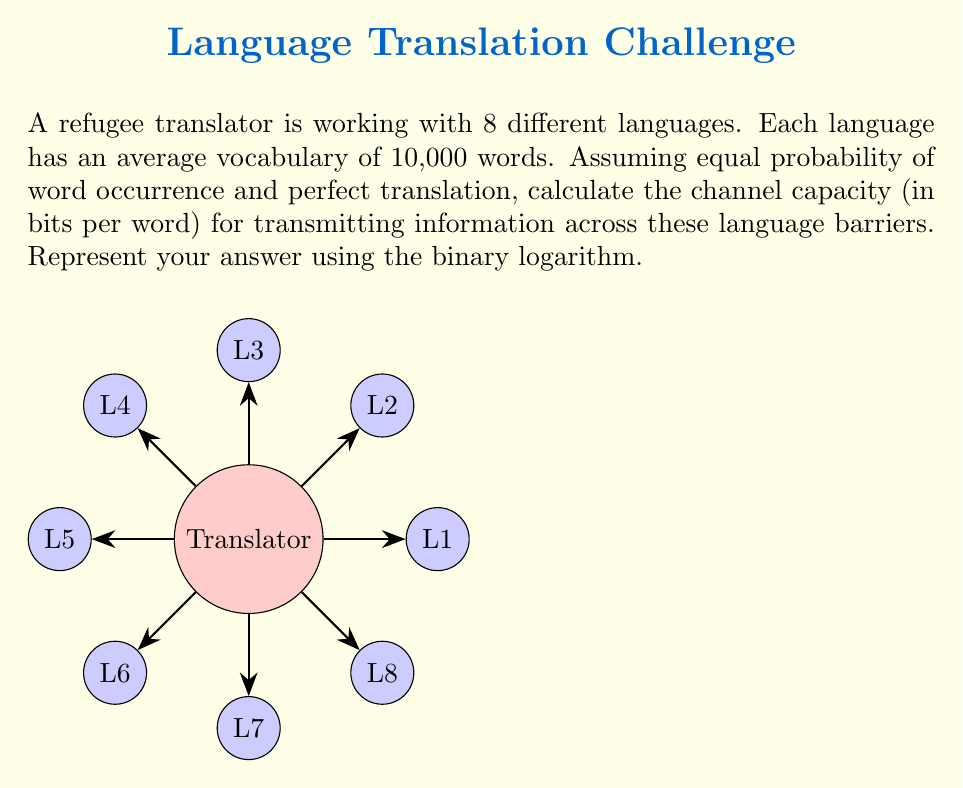Can you answer this question? To solve this problem, we'll use the concept of channel capacity from information theory. The channel capacity represents the maximum amount of information that can be reliably transmitted over a communication channel.

Step 1: Determine the number of possible outcomes (words)
In this case, we have 8 languages, each with 10,000 words.
Total possible outcomes = 8 × 10,000 = 80,000 words

Step 2: Calculate the information content using the binary logarithm
The information content (in bits) is given by the binary logarithm of the number of possible outcomes.

Information content = $\log_2(80,000)$

Step 3: Simplify the logarithm
$\log_2(80,000) = \log_2(8 \times 10,000)$
$= \log_2(8) + \log_2(10,000)$
$= 3 + \log_2(10,000)$
$= 3 + \log_2(10^4)$
$= 3 + 4 \log_2(10)$
$\approx 3 + 4 \times 3.32193 = 16.28772$ bits

Therefore, the channel capacity for transmitting information across these language barriers is approximately 16.28772 bits per word.
Answer: $\log_2(8) + \log_2(10,000) \approx 16.28772$ bits/word 